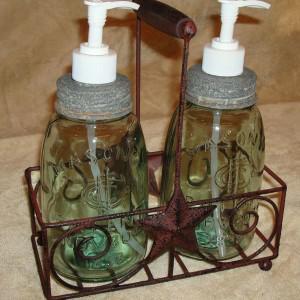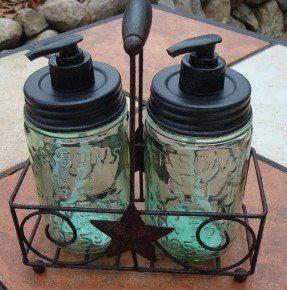The first image is the image on the left, the second image is the image on the right. Evaluate the accuracy of this statement regarding the images: "At least one bottle dispenser is facing left.". Is it true? Answer yes or no. Yes. The first image is the image on the left, the second image is the image on the right. Given the left and right images, does the statement "Each image shows a carrier holding two pump-top jars." hold true? Answer yes or no. Yes. 